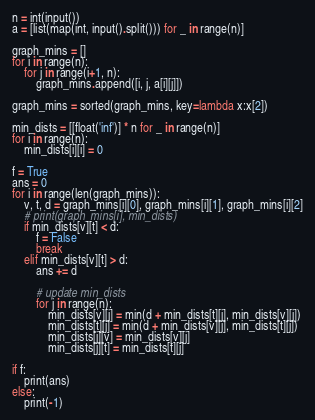<code> <loc_0><loc_0><loc_500><loc_500><_Python_>n = int(input())
a = [list(map(int, input().split())) for _ in range(n)]

graph_mins = []
for i in range(n):
    for j in range(i+1, n):
        graph_mins.append([i, j, a[i][j]])

graph_mins = sorted(graph_mins, key=lambda x:x[2])

min_dists = [[float('inf')] * n for _ in range(n)]
for i in range(n):
    min_dists[i][i] = 0

f = True
ans = 0
for i in range(len(graph_mins)):
    v, t, d = graph_mins[i][0], graph_mins[i][1], graph_mins[i][2]
    # print(graph_mins[i], min_dists)
    if min_dists[v][t] < d:
        f = False
        break
    elif min_dists[v][t] > d:
        ans += d

        # update min_dists
        for j in range(n):
            min_dists[v][j] = min(d + min_dists[t][j], min_dists[v][j])
            min_dists[t][j] = min(d + min_dists[v][j], min_dists[t][j])
            min_dists[j][v] = min_dists[v][j]
            min_dists[j][t] = min_dists[t][j]

if f:
    print(ans)
else:
    print(-1)
</code> 